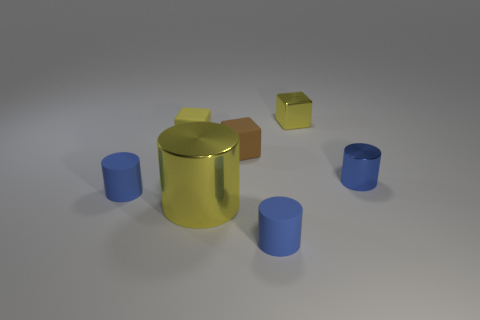Is the number of yellow matte blocks right of the blue metallic cylinder greater than the number of brown cubes that are left of the big yellow cylinder?
Ensure brevity in your answer.  No. What number of large things have the same color as the large metallic cylinder?
Make the answer very short. 0. There is a yellow cube that is made of the same material as the brown thing; what size is it?
Keep it short and to the point. Small. How many things are either yellow things that are on the left side of the tiny brown object or small matte blocks?
Give a very brief answer. 3. There is a small metallic object in front of the shiny cube; is its color the same as the big object?
Offer a terse response. No. The yellow rubber object that is the same shape as the tiny brown object is what size?
Your response must be concise. Small. What is the color of the tiny thing that is in front of the cylinder that is to the left of the yellow metal object in front of the yellow shiny block?
Your answer should be very brief. Blue. Does the large cylinder have the same material as the brown thing?
Make the answer very short. No. Is there a big yellow cylinder that is to the right of the blue cylinder behind the blue matte thing that is behind the large yellow metallic cylinder?
Offer a terse response. No. Is the color of the big thing the same as the tiny metallic cylinder?
Your answer should be compact. No. 